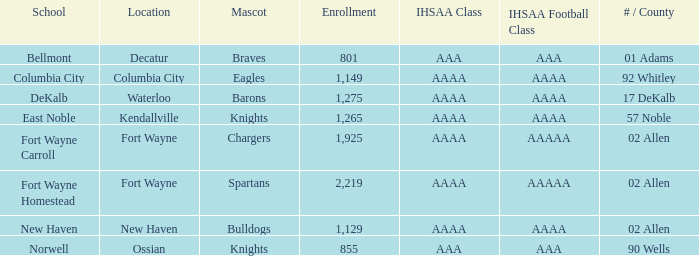What's the enrollment for Kendallville? 1265.0. 